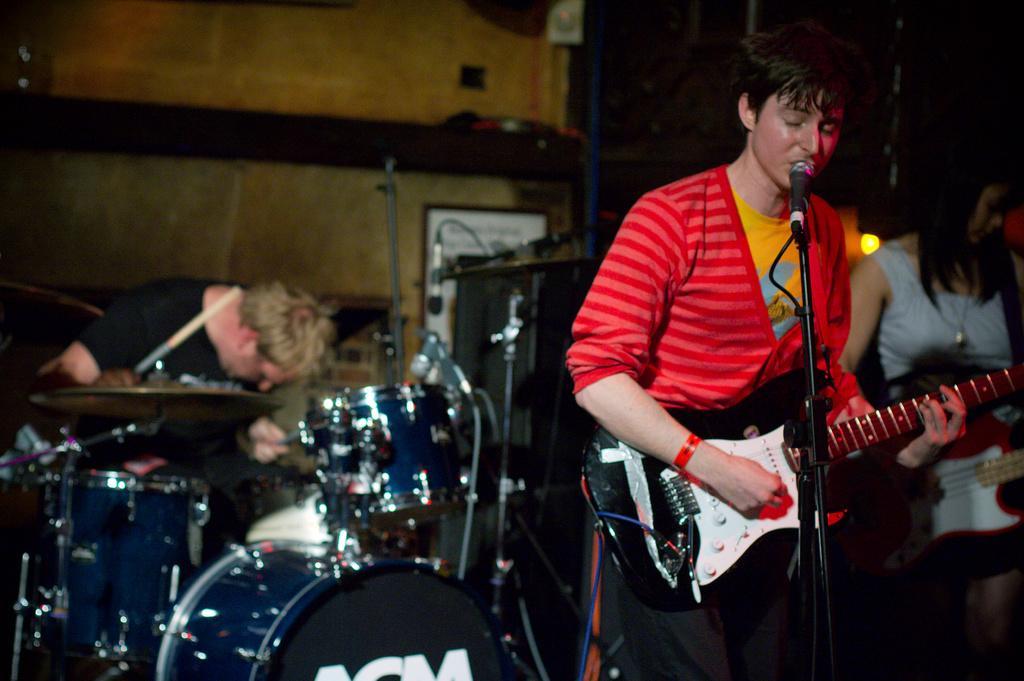Could you give a brief overview of what you see in this image? This is the image of the man standing and playing the guitar , a woman standing and playing the guitar and the back ground we have a person playing the drums. 